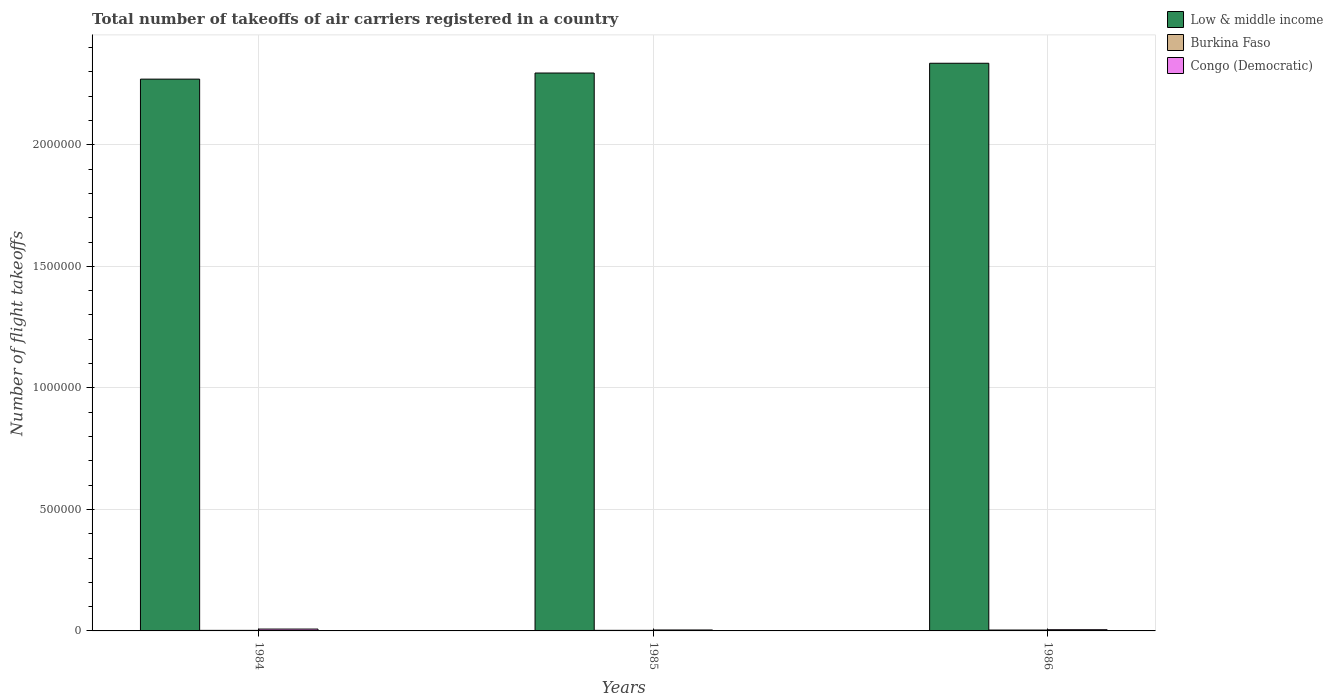How many different coloured bars are there?
Your answer should be very brief. 3. How many groups of bars are there?
Ensure brevity in your answer.  3. Are the number of bars per tick equal to the number of legend labels?
Offer a terse response. Yes. What is the label of the 1st group of bars from the left?
Give a very brief answer. 1984. What is the total number of flight takeoffs in Burkina Faso in 1985?
Offer a very short reply. 2400. Across all years, what is the maximum total number of flight takeoffs in Congo (Democratic)?
Give a very brief answer. 7600. Across all years, what is the minimum total number of flight takeoffs in Low & middle income?
Your answer should be compact. 2.27e+06. In which year was the total number of flight takeoffs in Low & middle income minimum?
Your response must be concise. 1984. What is the total total number of flight takeoffs in Low & middle income in the graph?
Provide a succinct answer. 6.90e+06. What is the difference between the total number of flight takeoffs in Congo (Democratic) in 1985 and that in 1986?
Provide a short and direct response. -1100. What is the difference between the total number of flight takeoffs in Low & middle income in 1986 and the total number of flight takeoffs in Burkina Faso in 1985?
Your answer should be compact. 2.33e+06. What is the average total number of flight takeoffs in Low & middle income per year?
Your response must be concise. 2.30e+06. In the year 1985, what is the difference between the total number of flight takeoffs in Burkina Faso and total number of flight takeoffs in Congo (Democratic)?
Your answer should be very brief. -1500. In how many years, is the total number of flight takeoffs in Low & middle income greater than 300000?
Ensure brevity in your answer.  3. What is the ratio of the total number of flight takeoffs in Burkina Faso in 1984 to that in 1985?
Your answer should be very brief. 0.96. What is the difference between the highest and the second highest total number of flight takeoffs in Low & middle income?
Your answer should be compact. 4.02e+04. What is the difference between the highest and the lowest total number of flight takeoffs in Congo (Democratic)?
Your response must be concise. 3700. In how many years, is the total number of flight takeoffs in Congo (Democratic) greater than the average total number of flight takeoffs in Congo (Democratic) taken over all years?
Offer a terse response. 1. Is the sum of the total number of flight takeoffs in Burkina Faso in 1985 and 1986 greater than the maximum total number of flight takeoffs in Congo (Democratic) across all years?
Offer a very short reply. No. Is it the case that in every year, the sum of the total number of flight takeoffs in Congo (Democratic) and total number of flight takeoffs in Burkina Faso is greater than the total number of flight takeoffs in Low & middle income?
Provide a succinct answer. No. Are all the bars in the graph horizontal?
Your answer should be compact. No. What is the difference between two consecutive major ticks on the Y-axis?
Your answer should be very brief. 5.00e+05. Does the graph contain grids?
Offer a terse response. Yes. How are the legend labels stacked?
Provide a succinct answer. Vertical. What is the title of the graph?
Offer a terse response. Total number of takeoffs of air carriers registered in a country. Does "Lesotho" appear as one of the legend labels in the graph?
Provide a short and direct response. No. What is the label or title of the X-axis?
Provide a succinct answer. Years. What is the label or title of the Y-axis?
Offer a terse response. Number of flight takeoffs. What is the Number of flight takeoffs in Low & middle income in 1984?
Your response must be concise. 2.27e+06. What is the Number of flight takeoffs of Burkina Faso in 1984?
Keep it short and to the point. 2300. What is the Number of flight takeoffs in Congo (Democratic) in 1984?
Your answer should be very brief. 7600. What is the Number of flight takeoffs in Low & middle income in 1985?
Keep it short and to the point. 2.30e+06. What is the Number of flight takeoffs in Burkina Faso in 1985?
Provide a short and direct response. 2400. What is the Number of flight takeoffs of Congo (Democratic) in 1985?
Offer a terse response. 3900. What is the Number of flight takeoffs in Low & middle income in 1986?
Keep it short and to the point. 2.34e+06. What is the Number of flight takeoffs of Burkina Faso in 1986?
Ensure brevity in your answer.  3600. What is the Number of flight takeoffs in Congo (Democratic) in 1986?
Your answer should be very brief. 5000. Across all years, what is the maximum Number of flight takeoffs in Low & middle income?
Your response must be concise. 2.34e+06. Across all years, what is the maximum Number of flight takeoffs of Burkina Faso?
Your answer should be very brief. 3600. Across all years, what is the maximum Number of flight takeoffs of Congo (Democratic)?
Provide a short and direct response. 7600. Across all years, what is the minimum Number of flight takeoffs in Low & middle income?
Offer a very short reply. 2.27e+06. Across all years, what is the minimum Number of flight takeoffs of Burkina Faso?
Offer a terse response. 2300. Across all years, what is the minimum Number of flight takeoffs in Congo (Democratic)?
Your answer should be compact. 3900. What is the total Number of flight takeoffs of Low & middle income in the graph?
Offer a terse response. 6.90e+06. What is the total Number of flight takeoffs in Burkina Faso in the graph?
Your response must be concise. 8300. What is the total Number of flight takeoffs in Congo (Democratic) in the graph?
Ensure brevity in your answer.  1.65e+04. What is the difference between the Number of flight takeoffs in Low & middle income in 1984 and that in 1985?
Give a very brief answer. -2.51e+04. What is the difference between the Number of flight takeoffs in Burkina Faso in 1984 and that in 1985?
Make the answer very short. -100. What is the difference between the Number of flight takeoffs of Congo (Democratic) in 1984 and that in 1985?
Your answer should be very brief. 3700. What is the difference between the Number of flight takeoffs of Low & middle income in 1984 and that in 1986?
Offer a very short reply. -6.53e+04. What is the difference between the Number of flight takeoffs of Burkina Faso in 1984 and that in 1986?
Your response must be concise. -1300. What is the difference between the Number of flight takeoffs of Congo (Democratic) in 1984 and that in 1986?
Offer a terse response. 2600. What is the difference between the Number of flight takeoffs of Low & middle income in 1985 and that in 1986?
Provide a short and direct response. -4.02e+04. What is the difference between the Number of flight takeoffs in Burkina Faso in 1985 and that in 1986?
Ensure brevity in your answer.  -1200. What is the difference between the Number of flight takeoffs of Congo (Democratic) in 1985 and that in 1986?
Offer a very short reply. -1100. What is the difference between the Number of flight takeoffs in Low & middle income in 1984 and the Number of flight takeoffs in Burkina Faso in 1985?
Your response must be concise. 2.27e+06. What is the difference between the Number of flight takeoffs in Low & middle income in 1984 and the Number of flight takeoffs in Congo (Democratic) in 1985?
Give a very brief answer. 2.27e+06. What is the difference between the Number of flight takeoffs in Burkina Faso in 1984 and the Number of flight takeoffs in Congo (Democratic) in 1985?
Keep it short and to the point. -1600. What is the difference between the Number of flight takeoffs of Low & middle income in 1984 and the Number of flight takeoffs of Burkina Faso in 1986?
Keep it short and to the point. 2.27e+06. What is the difference between the Number of flight takeoffs in Low & middle income in 1984 and the Number of flight takeoffs in Congo (Democratic) in 1986?
Ensure brevity in your answer.  2.27e+06. What is the difference between the Number of flight takeoffs in Burkina Faso in 1984 and the Number of flight takeoffs in Congo (Democratic) in 1986?
Offer a terse response. -2700. What is the difference between the Number of flight takeoffs of Low & middle income in 1985 and the Number of flight takeoffs of Burkina Faso in 1986?
Your answer should be compact. 2.29e+06. What is the difference between the Number of flight takeoffs in Low & middle income in 1985 and the Number of flight takeoffs in Congo (Democratic) in 1986?
Offer a very short reply. 2.29e+06. What is the difference between the Number of flight takeoffs in Burkina Faso in 1985 and the Number of flight takeoffs in Congo (Democratic) in 1986?
Make the answer very short. -2600. What is the average Number of flight takeoffs of Low & middle income per year?
Provide a succinct answer. 2.30e+06. What is the average Number of flight takeoffs of Burkina Faso per year?
Give a very brief answer. 2766.67. What is the average Number of flight takeoffs of Congo (Democratic) per year?
Provide a short and direct response. 5500. In the year 1984, what is the difference between the Number of flight takeoffs of Low & middle income and Number of flight takeoffs of Burkina Faso?
Provide a short and direct response. 2.27e+06. In the year 1984, what is the difference between the Number of flight takeoffs in Low & middle income and Number of flight takeoffs in Congo (Democratic)?
Your response must be concise. 2.26e+06. In the year 1984, what is the difference between the Number of flight takeoffs in Burkina Faso and Number of flight takeoffs in Congo (Democratic)?
Offer a terse response. -5300. In the year 1985, what is the difference between the Number of flight takeoffs in Low & middle income and Number of flight takeoffs in Burkina Faso?
Offer a terse response. 2.29e+06. In the year 1985, what is the difference between the Number of flight takeoffs in Low & middle income and Number of flight takeoffs in Congo (Democratic)?
Your response must be concise. 2.29e+06. In the year 1985, what is the difference between the Number of flight takeoffs of Burkina Faso and Number of flight takeoffs of Congo (Democratic)?
Make the answer very short. -1500. In the year 1986, what is the difference between the Number of flight takeoffs in Low & middle income and Number of flight takeoffs in Burkina Faso?
Keep it short and to the point. 2.33e+06. In the year 1986, what is the difference between the Number of flight takeoffs in Low & middle income and Number of flight takeoffs in Congo (Democratic)?
Provide a succinct answer. 2.33e+06. In the year 1986, what is the difference between the Number of flight takeoffs in Burkina Faso and Number of flight takeoffs in Congo (Democratic)?
Make the answer very short. -1400. What is the ratio of the Number of flight takeoffs in Low & middle income in 1984 to that in 1985?
Offer a terse response. 0.99. What is the ratio of the Number of flight takeoffs in Congo (Democratic) in 1984 to that in 1985?
Your answer should be compact. 1.95. What is the ratio of the Number of flight takeoffs in Low & middle income in 1984 to that in 1986?
Your response must be concise. 0.97. What is the ratio of the Number of flight takeoffs in Burkina Faso in 1984 to that in 1986?
Your response must be concise. 0.64. What is the ratio of the Number of flight takeoffs in Congo (Democratic) in 1984 to that in 1986?
Your answer should be very brief. 1.52. What is the ratio of the Number of flight takeoffs of Low & middle income in 1985 to that in 1986?
Provide a short and direct response. 0.98. What is the ratio of the Number of flight takeoffs in Burkina Faso in 1985 to that in 1986?
Offer a very short reply. 0.67. What is the ratio of the Number of flight takeoffs of Congo (Democratic) in 1985 to that in 1986?
Provide a succinct answer. 0.78. What is the difference between the highest and the second highest Number of flight takeoffs in Low & middle income?
Make the answer very short. 4.02e+04. What is the difference between the highest and the second highest Number of flight takeoffs of Burkina Faso?
Make the answer very short. 1200. What is the difference between the highest and the second highest Number of flight takeoffs of Congo (Democratic)?
Your answer should be very brief. 2600. What is the difference between the highest and the lowest Number of flight takeoffs of Low & middle income?
Keep it short and to the point. 6.53e+04. What is the difference between the highest and the lowest Number of flight takeoffs in Burkina Faso?
Make the answer very short. 1300. What is the difference between the highest and the lowest Number of flight takeoffs of Congo (Democratic)?
Provide a succinct answer. 3700. 